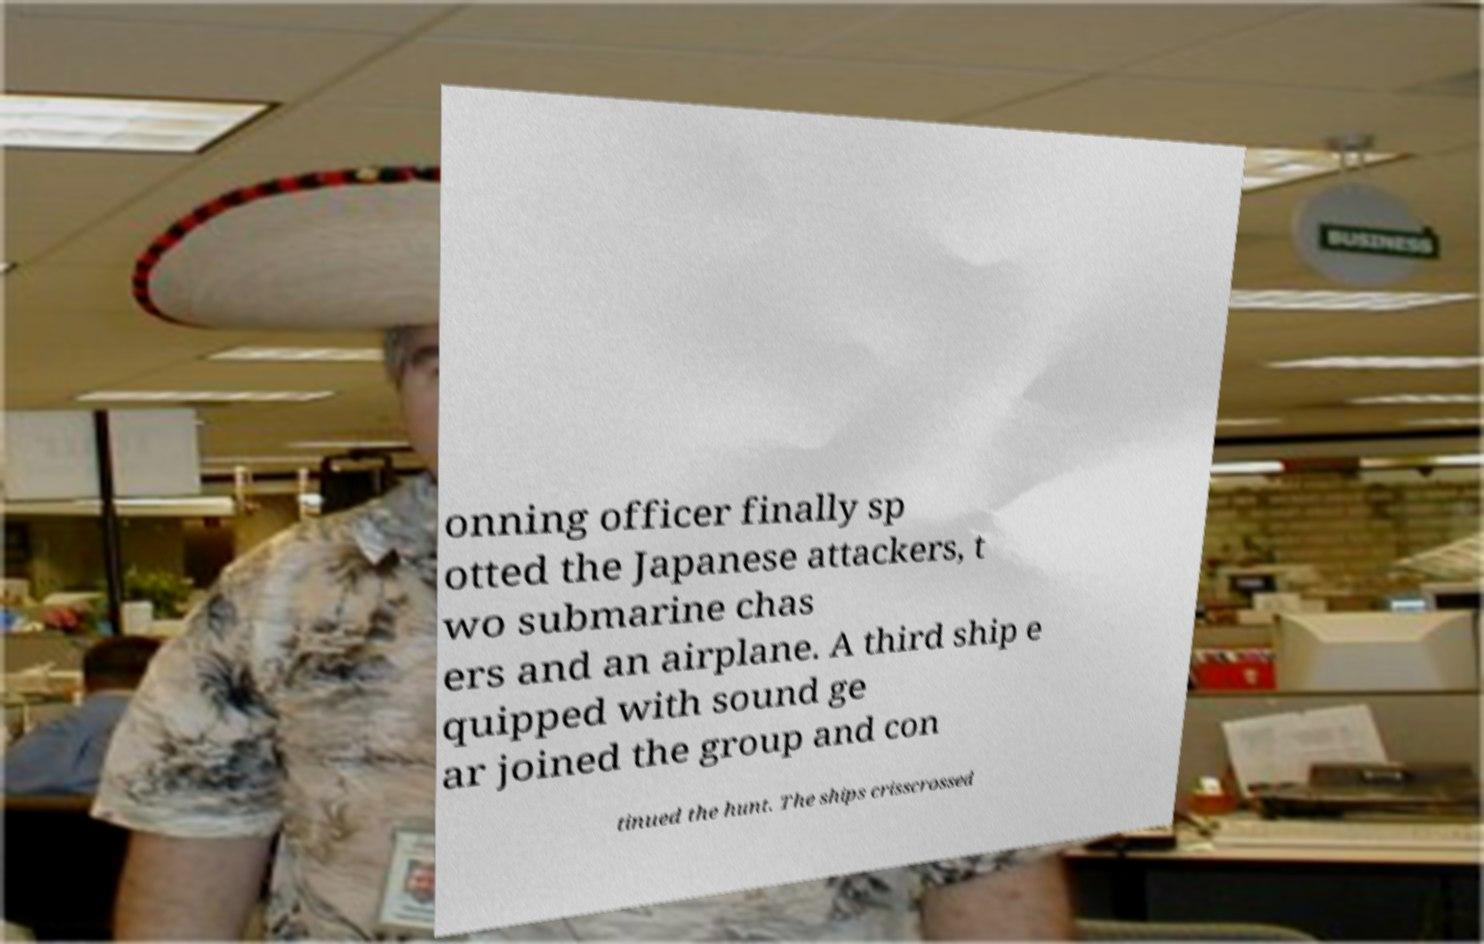For documentation purposes, I need the text within this image transcribed. Could you provide that? onning officer finally sp otted the Japanese attackers, t wo submarine chas ers and an airplane. A third ship e quipped with sound ge ar joined the group and con tinued the hunt. The ships crisscrossed 